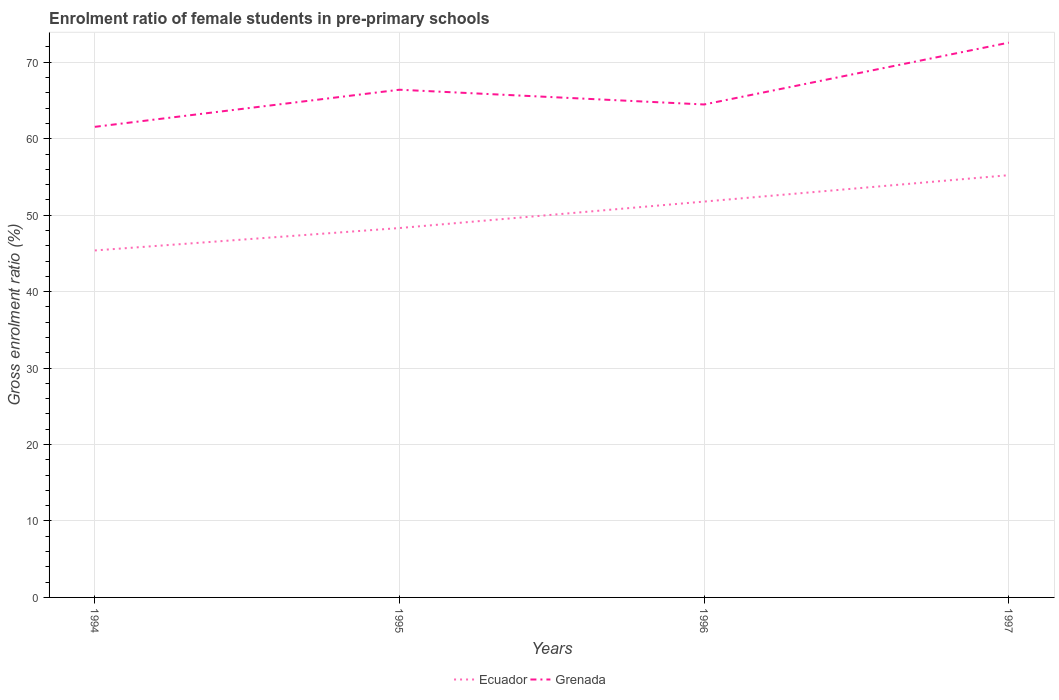How many different coloured lines are there?
Make the answer very short. 2. Is the number of lines equal to the number of legend labels?
Keep it short and to the point. Yes. Across all years, what is the maximum enrolment ratio of female students in pre-primary schools in Ecuador?
Keep it short and to the point. 45.39. What is the total enrolment ratio of female students in pre-primary schools in Grenada in the graph?
Your response must be concise. -4.85. What is the difference between the highest and the second highest enrolment ratio of female students in pre-primary schools in Grenada?
Provide a succinct answer. 11.01. Is the enrolment ratio of female students in pre-primary schools in Grenada strictly greater than the enrolment ratio of female students in pre-primary schools in Ecuador over the years?
Your response must be concise. No. How many years are there in the graph?
Ensure brevity in your answer.  4. Where does the legend appear in the graph?
Offer a terse response. Bottom center. What is the title of the graph?
Ensure brevity in your answer.  Enrolment ratio of female students in pre-primary schools. Does "United Arab Emirates" appear as one of the legend labels in the graph?
Your answer should be very brief. No. What is the label or title of the X-axis?
Offer a terse response. Years. What is the Gross enrolment ratio (%) of Ecuador in 1994?
Keep it short and to the point. 45.39. What is the Gross enrolment ratio (%) in Grenada in 1994?
Offer a very short reply. 61.55. What is the Gross enrolment ratio (%) of Ecuador in 1995?
Offer a very short reply. 48.32. What is the Gross enrolment ratio (%) of Grenada in 1995?
Provide a short and direct response. 66.41. What is the Gross enrolment ratio (%) in Ecuador in 1996?
Offer a very short reply. 51.78. What is the Gross enrolment ratio (%) of Grenada in 1996?
Keep it short and to the point. 64.48. What is the Gross enrolment ratio (%) in Ecuador in 1997?
Make the answer very short. 55.23. What is the Gross enrolment ratio (%) of Grenada in 1997?
Offer a very short reply. 72.57. Across all years, what is the maximum Gross enrolment ratio (%) of Ecuador?
Make the answer very short. 55.23. Across all years, what is the maximum Gross enrolment ratio (%) in Grenada?
Provide a succinct answer. 72.57. Across all years, what is the minimum Gross enrolment ratio (%) of Ecuador?
Provide a succinct answer. 45.39. Across all years, what is the minimum Gross enrolment ratio (%) of Grenada?
Offer a very short reply. 61.55. What is the total Gross enrolment ratio (%) in Ecuador in the graph?
Offer a very short reply. 200.72. What is the total Gross enrolment ratio (%) in Grenada in the graph?
Offer a very short reply. 265.01. What is the difference between the Gross enrolment ratio (%) in Ecuador in 1994 and that in 1995?
Your response must be concise. -2.93. What is the difference between the Gross enrolment ratio (%) of Grenada in 1994 and that in 1995?
Offer a very short reply. -4.85. What is the difference between the Gross enrolment ratio (%) in Ecuador in 1994 and that in 1996?
Keep it short and to the point. -6.39. What is the difference between the Gross enrolment ratio (%) in Grenada in 1994 and that in 1996?
Offer a terse response. -2.92. What is the difference between the Gross enrolment ratio (%) of Ecuador in 1994 and that in 1997?
Offer a terse response. -9.85. What is the difference between the Gross enrolment ratio (%) of Grenada in 1994 and that in 1997?
Give a very brief answer. -11.01. What is the difference between the Gross enrolment ratio (%) of Ecuador in 1995 and that in 1996?
Provide a succinct answer. -3.46. What is the difference between the Gross enrolment ratio (%) in Grenada in 1995 and that in 1996?
Give a very brief answer. 1.93. What is the difference between the Gross enrolment ratio (%) in Ecuador in 1995 and that in 1997?
Ensure brevity in your answer.  -6.91. What is the difference between the Gross enrolment ratio (%) of Grenada in 1995 and that in 1997?
Keep it short and to the point. -6.16. What is the difference between the Gross enrolment ratio (%) of Ecuador in 1996 and that in 1997?
Offer a very short reply. -3.45. What is the difference between the Gross enrolment ratio (%) of Grenada in 1996 and that in 1997?
Make the answer very short. -8.09. What is the difference between the Gross enrolment ratio (%) in Ecuador in 1994 and the Gross enrolment ratio (%) in Grenada in 1995?
Offer a terse response. -21.02. What is the difference between the Gross enrolment ratio (%) in Ecuador in 1994 and the Gross enrolment ratio (%) in Grenada in 1996?
Your answer should be compact. -19.09. What is the difference between the Gross enrolment ratio (%) in Ecuador in 1994 and the Gross enrolment ratio (%) in Grenada in 1997?
Give a very brief answer. -27.18. What is the difference between the Gross enrolment ratio (%) of Ecuador in 1995 and the Gross enrolment ratio (%) of Grenada in 1996?
Give a very brief answer. -16.16. What is the difference between the Gross enrolment ratio (%) of Ecuador in 1995 and the Gross enrolment ratio (%) of Grenada in 1997?
Keep it short and to the point. -24.25. What is the difference between the Gross enrolment ratio (%) of Ecuador in 1996 and the Gross enrolment ratio (%) of Grenada in 1997?
Provide a succinct answer. -20.79. What is the average Gross enrolment ratio (%) in Ecuador per year?
Your answer should be very brief. 50.18. What is the average Gross enrolment ratio (%) in Grenada per year?
Give a very brief answer. 66.25. In the year 1994, what is the difference between the Gross enrolment ratio (%) in Ecuador and Gross enrolment ratio (%) in Grenada?
Offer a very short reply. -16.17. In the year 1995, what is the difference between the Gross enrolment ratio (%) in Ecuador and Gross enrolment ratio (%) in Grenada?
Make the answer very short. -18.09. In the year 1996, what is the difference between the Gross enrolment ratio (%) in Ecuador and Gross enrolment ratio (%) in Grenada?
Keep it short and to the point. -12.7. In the year 1997, what is the difference between the Gross enrolment ratio (%) of Ecuador and Gross enrolment ratio (%) of Grenada?
Keep it short and to the point. -17.34. What is the ratio of the Gross enrolment ratio (%) in Ecuador in 1994 to that in 1995?
Your response must be concise. 0.94. What is the ratio of the Gross enrolment ratio (%) of Grenada in 1994 to that in 1995?
Keep it short and to the point. 0.93. What is the ratio of the Gross enrolment ratio (%) in Ecuador in 1994 to that in 1996?
Offer a very short reply. 0.88. What is the ratio of the Gross enrolment ratio (%) in Grenada in 1994 to that in 1996?
Ensure brevity in your answer.  0.95. What is the ratio of the Gross enrolment ratio (%) in Ecuador in 1994 to that in 1997?
Provide a short and direct response. 0.82. What is the ratio of the Gross enrolment ratio (%) of Grenada in 1994 to that in 1997?
Your answer should be compact. 0.85. What is the ratio of the Gross enrolment ratio (%) in Ecuador in 1995 to that in 1996?
Offer a very short reply. 0.93. What is the ratio of the Gross enrolment ratio (%) of Grenada in 1995 to that in 1996?
Offer a very short reply. 1.03. What is the ratio of the Gross enrolment ratio (%) in Ecuador in 1995 to that in 1997?
Provide a succinct answer. 0.87. What is the ratio of the Gross enrolment ratio (%) of Grenada in 1995 to that in 1997?
Keep it short and to the point. 0.92. What is the ratio of the Gross enrolment ratio (%) in Ecuador in 1996 to that in 1997?
Provide a short and direct response. 0.94. What is the ratio of the Gross enrolment ratio (%) in Grenada in 1996 to that in 1997?
Make the answer very short. 0.89. What is the difference between the highest and the second highest Gross enrolment ratio (%) of Ecuador?
Your answer should be very brief. 3.45. What is the difference between the highest and the second highest Gross enrolment ratio (%) in Grenada?
Offer a terse response. 6.16. What is the difference between the highest and the lowest Gross enrolment ratio (%) in Ecuador?
Provide a short and direct response. 9.85. What is the difference between the highest and the lowest Gross enrolment ratio (%) of Grenada?
Keep it short and to the point. 11.01. 